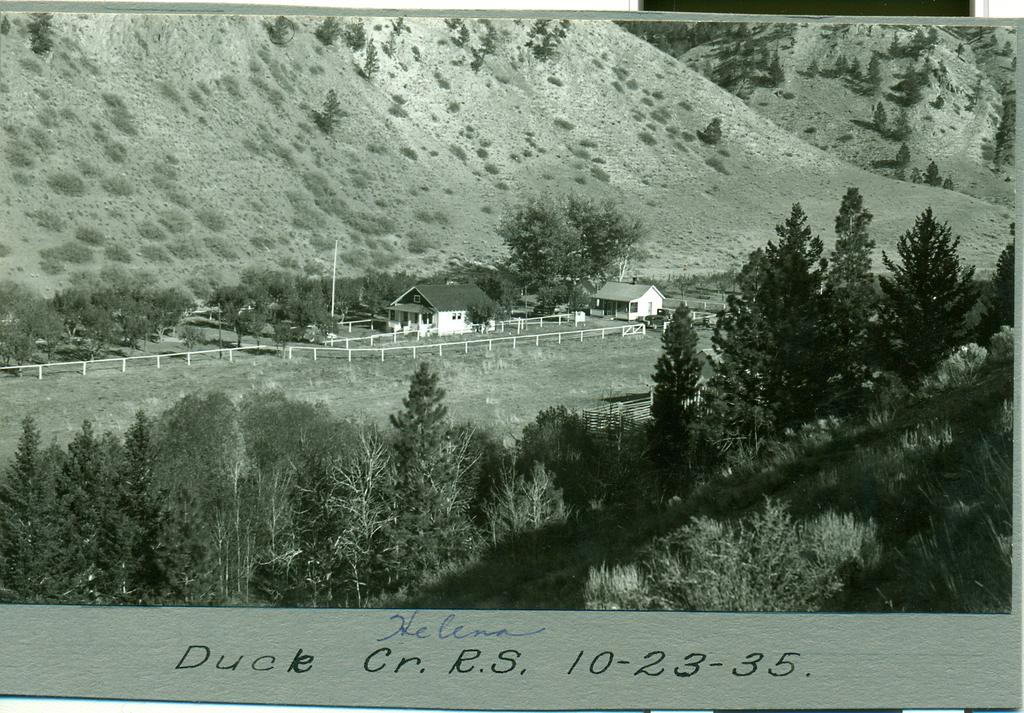What type of vegetation can be seen in the image? There are trees in the image. What type of structures are present in the image? There are houses in the image. What can be seen in the distance in the image? There are mountains visible in the background of the image. What is the condition of the sky in the background of the image? The sky is clear in the background of the image. What type of shoes can be seen on the trees in the image? There are no shoes present on the trees in the image; only trees and houses are visible. 